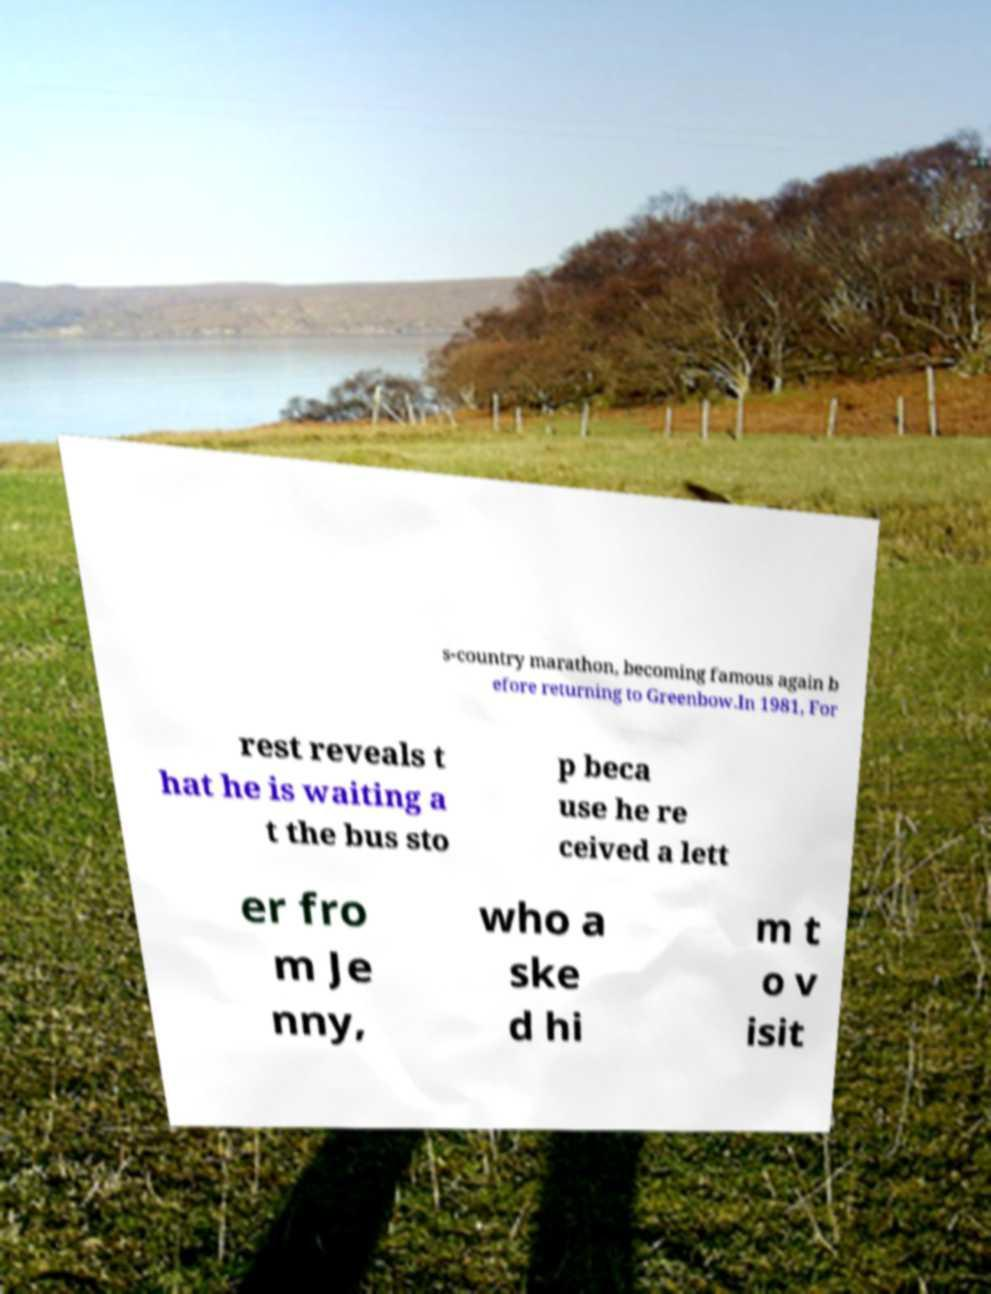Could you assist in decoding the text presented in this image and type it out clearly? s-country marathon, becoming famous again b efore returning to Greenbow.In 1981, For rest reveals t hat he is waiting a t the bus sto p beca use he re ceived a lett er fro m Je nny, who a ske d hi m t o v isit 